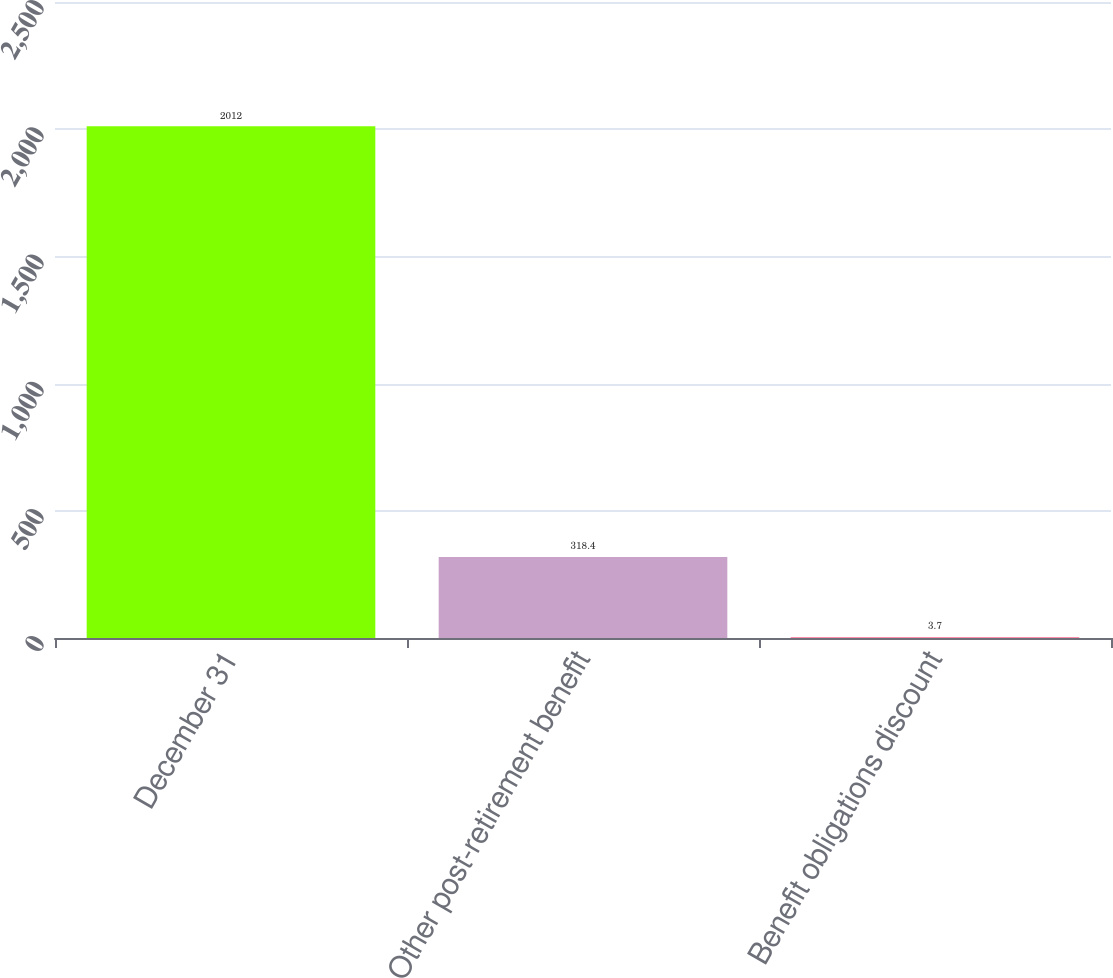<chart> <loc_0><loc_0><loc_500><loc_500><bar_chart><fcel>December 31<fcel>Other post-retirement benefit<fcel>Benefit obligations discount<nl><fcel>2012<fcel>318.4<fcel>3.7<nl></chart> 